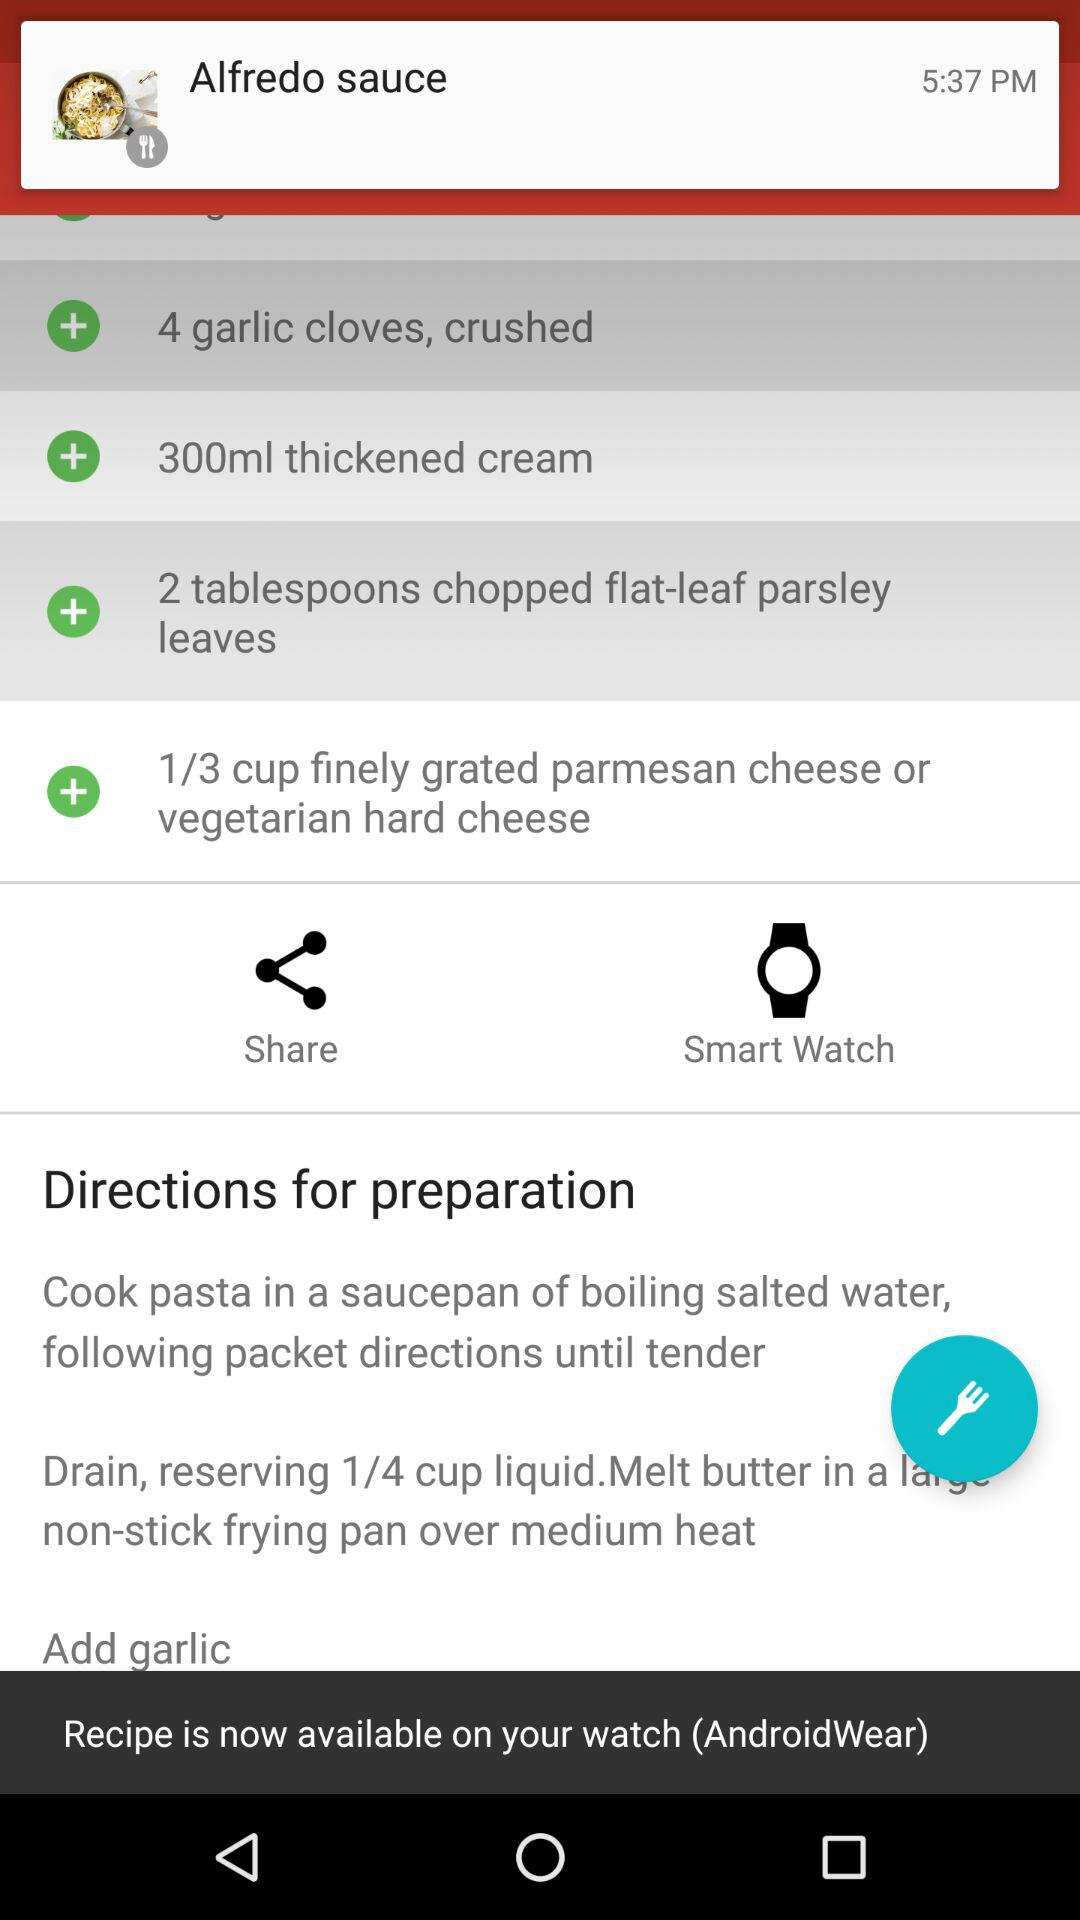How many milliliters of thickened cream are required? There are 300 milliliters of thickened cream required. 